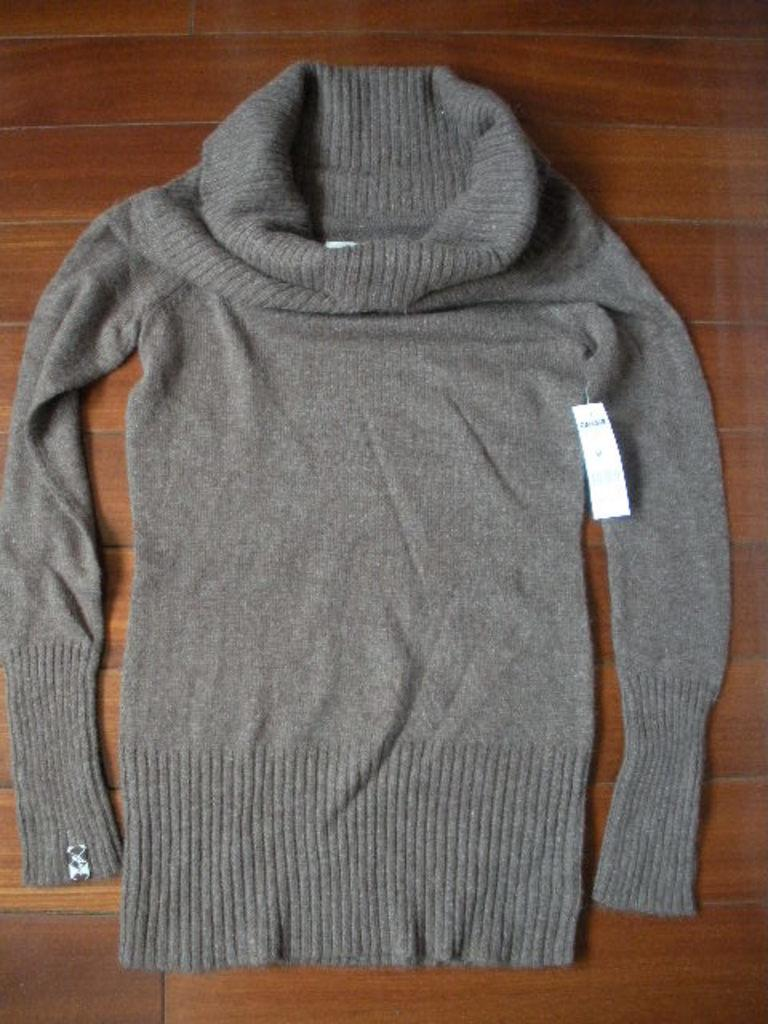What type of clothing is in the center of the image? There is a woolen t-shirt in the center of the image. Can you describe the position of the woolen t-shirt in the image? The woolen t-shirt is in the center of the image. What type of toothbrush is used to clean the woolen t-shirt in the image? There is no toothbrush present in the image, and the woolen t-shirt is not being cleaned. 